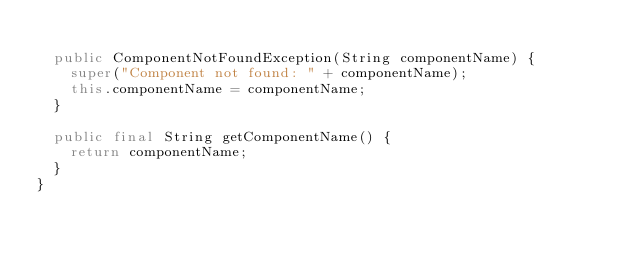Convert code to text. <code><loc_0><loc_0><loc_500><loc_500><_Java_>
  public ComponentNotFoundException(String componentName) {
    super("Component not found: " + componentName);
    this.componentName = componentName;
  }

  public final String getComponentName() {
    return componentName;
  }
}
</code> 